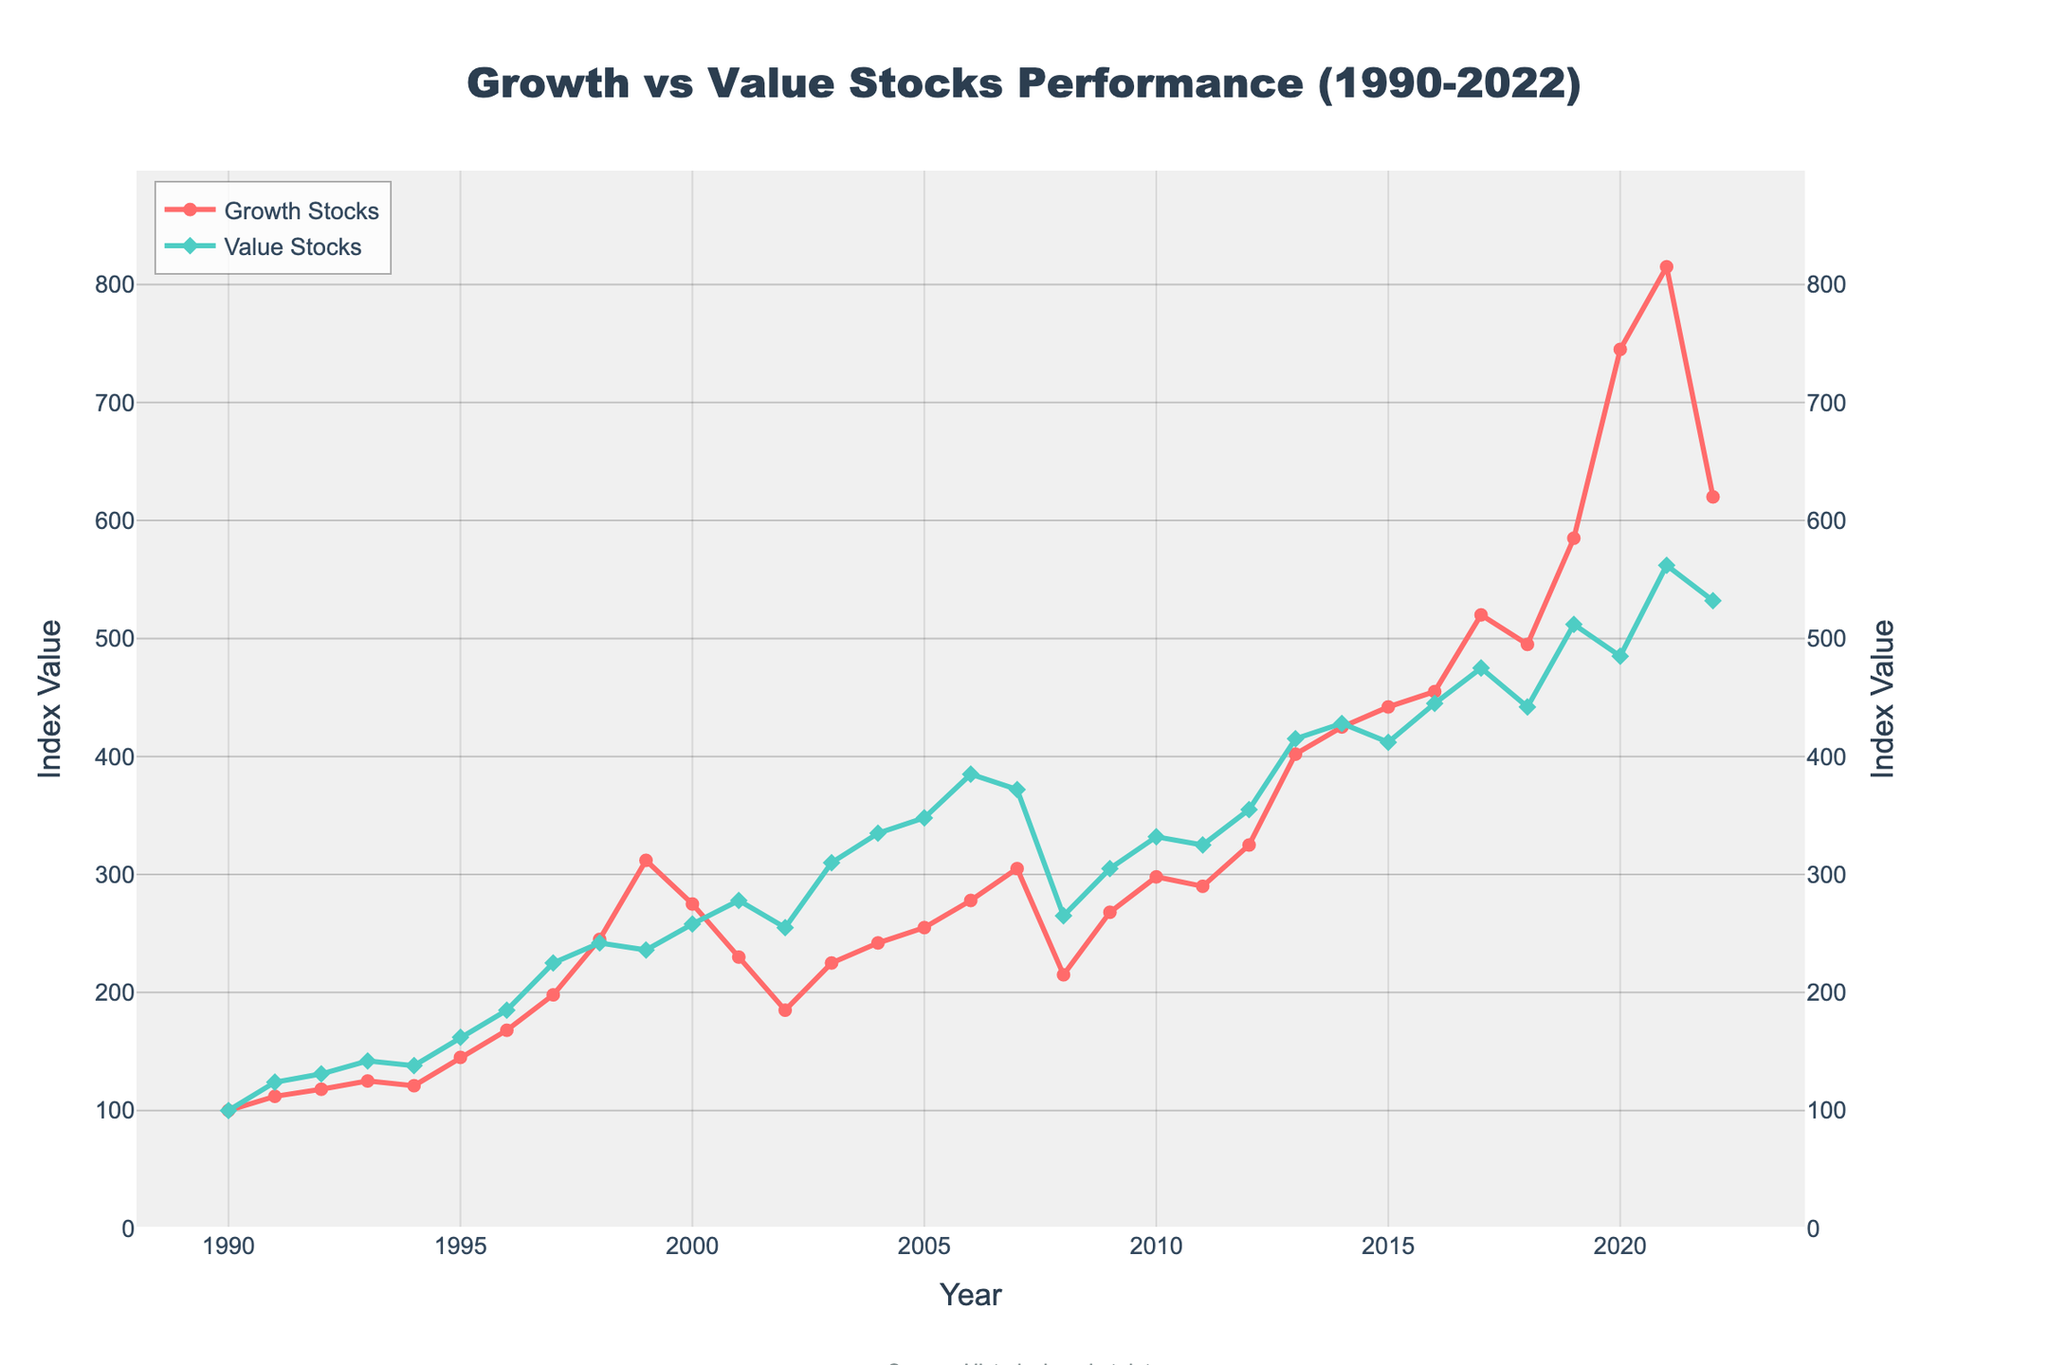What's the primary trend observed in Growth Stocks from 1990 to 2022? The figure shows Growth Stocks generally increase over time with a few dips, notably around the early 2000s and 2008-2009, clearly indicating an overall upward trend despite some volatility
Answer: Upward trend Which year experienced the highest value for Growth Stocks? By examining the figure, the peak of the Growth Stocks line occurs at the year 2021, indicating that this year had the highest value for Growth Stocks
Answer: 2021 How did Value Stocks perform in comparison to Growth Stocks in 2008? The figure shows a significant drop for both Growth and Value Stocks in 2008, but the drop is more pronounced for Growth Stocks. Growth Stocks had a value of 215 while Value Stocks had a value of 265
Answer: Value Stocks performed better What is the difference in Growth Stocks value between the years 1999 and 2000? By looking at the chart, the Growth Stocks value in 1999 is 312 and in 2000 is 275. Subtracting these values gives the difference: 312 - 275 = 37
Answer: 37 Which year shows the lowest value for Growth Stocks after the year 2000? Observing the figure, the lowest point for Growth Stocks after 2000 is in 2002, where the value is 185
Answer: 2002 When did Value Stocks first surpass a value of 400? By checking the trajectory of the Value Stocks line, it crosses the 400 mark in the year 2013
Answer: 2013 How does the performance of Growth Stocks in 2010 compare to Value Stocks in the same year? In 2010, the value of Growth Stocks is 298 and Value Stocks is 332 according to the chart, showing that Value Stocks outperformed Growth Stocks in this year
Answer: Value Stocks outperformed What was the index value of Growth Stocks when Value Stocks had their highest index value? From the figure, Value Stocks had their peak in 2013 at a value of 415. At the same time, Growth Stocks were at a value of 402
Answer: 402 Calculate the average of Growth Stocks' values from 2016 to 2020. The values for Growth Stocks from 2016 to 2020 are 455, 520, 495, 585, and 745. Summing these gives 2800, and the average is 2800 / 5 = 560
Answer: 560 